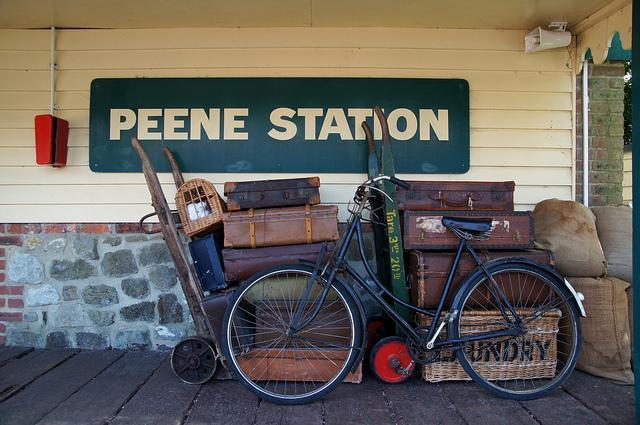How many bicycles are pictured here?
Give a very brief answer. 1. How many suitcases are visible?
Give a very brief answer. 8. How many people are in the water?
Give a very brief answer. 0. 